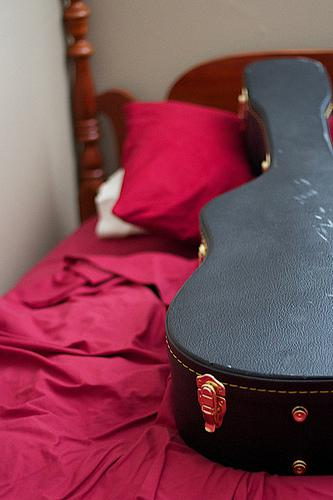Question: what is under the guitar?
Choices:
A. Blanket.
B. Pillow.
C. Sheets.
D. Comforter.
Answer with the letter. Answer: B Question: where was the picture taken?
Choices:
A. In a living room.
B. In a bedroom.
C. In a den.
D. In a kitchen.
Answer with the letter. Answer: B 